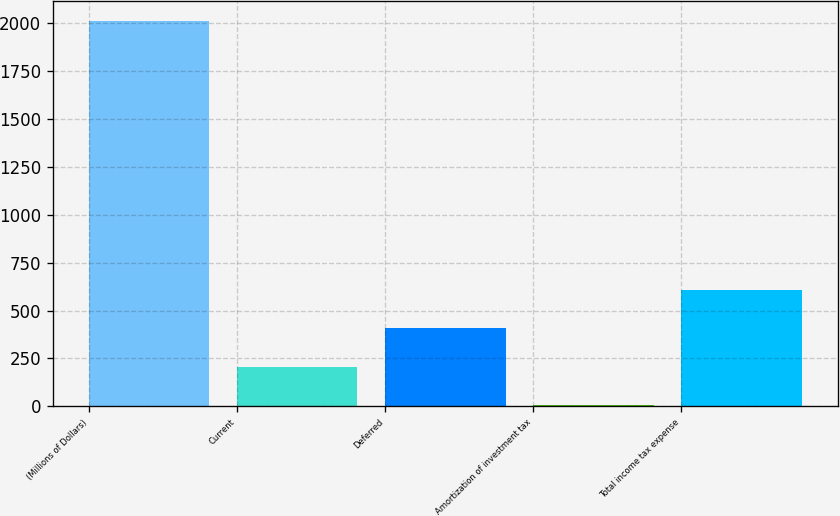Convert chart to OTSL. <chart><loc_0><loc_0><loc_500><loc_500><bar_chart><fcel>(Millions of Dollars)<fcel>Current<fcel>Deferred<fcel>Amortization of investment tax<fcel>Total income tax expense<nl><fcel>2014<fcel>206.8<fcel>407.6<fcel>6<fcel>608.4<nl></chart> 